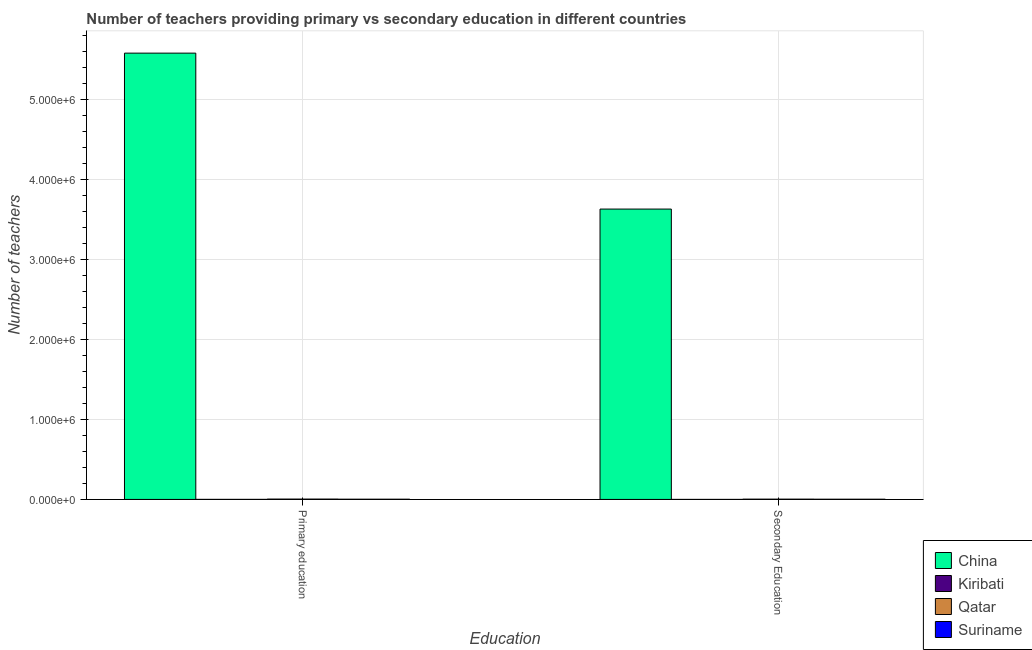Are the number of bars per tick equal to the number of legend labels?
Your answer should be very brief. Yes. Are the number of bars on each tick of the X-axis equal?
Give a very brief answer. Yes. How many bars are there on the 2nd tick from the right?
Your answer should be very brief. 4. What is the label of the 1st group of bars from the left?
Make the answer very short. Primary education. What is the number of secondary teachers in China?
Keep it short and to the point. 3.63e+06. Across all countries, what is the maximum number of primary teachers?
Ensure brevity in your answer.  5.58e+06. Across all countries, what is the minimum number of primary teachers?
Keep it short and to the point. 533. In which country was the number of secondary teachers minimum?
Make the answer very short. Kiribati. What is the total number of secondary teachers in the graph?
Your answer should be compact. 3.64e+06. What is the difference between the number of primary teachers in Kiribati and that in Qatar?
Provide a succinct answer. -3753. What is the difference between the number of secondary teachers in Suriname and the number of primary teachers in Kiribati?
Give a very brief answer. 1949. What is the average number of secondary teachers per country?
Offer a terse response. 9.09e+05. What is the difference between the number of secondary teachers and number of primary teachers in Kiribati?
Keep it short and to the point. -297. What is the ratio of the number of primary teachers in China to that in Suriname?
Offer a very short reply. 2078.11. In how many countries, is the number of primary teachers greater than the average number of primary teachers taken over all countries?
Your response must be concise. 1. What does the 1st bar from the right in Primary education represents?
Provide a short and direct response. Suriname. Are the values on the major ticks of Y-axis written in scientific E-notation?
Make the answer very short. Yes. Does the graph contain any zero values?
Keep it short and to the point. No. Does the graph contain grids?
Provide a succinct answer. Yes. Where does the legend appear in the graph?
Provide a short and direct response. Bottom right. What is the title of the graph?
Offer a terse response. Number of teachers providing primary vs secondary education in different countries. Does "Europe(all income levels)" appear as one of the legend labels in the graph?
Offer a very short reply. No. What is the label or title of the X-axis?
Make the answer very short. Education. What is the label or title of the Y-axis?
Offer a terse response. Number of teachers. What is the Number of teachers of China in Primary education?
Provide a succinct answer. 5.58e+06. What is the Number of teachers of Kiribati in Primary education?
Your response must be concise. 533. What is the Number of teachers in Qatar in Primary education?
Provide a succinct answer. 4286. What is the Number of teachers in Suriname in Primary education?
Offer a very short reply. 2686. What is the Number of teachers in China in Secondary Education?
Keep it short and to the point. 3.63e+06. What is the Number of teachers in Kiribati in Secondary Education?
Offer a very short reply. 236. What is the Number of teachers of Qatar in Secondary Education?
Provide a succinct answer. 3547. What is the Number of teachers in Suriname in Secondary Education?
Ensure brevity in your answer.  2482. Across all Education, what is the maximum Number of teachers in China?
Keep it short and to the point. 5.58e+06. Across all Education, what is the maximum Number of teachers of Kiribati?
Provide a short and direct response. 533. Across all Education, what is the maximum Number of teachers of Qatar?
Ensure brevity in your answer.  4286. Across all Education, what is the maximum Number of teachers in Suriname?
Provide a succinct answer. 2686. Across all Education, what is the minimum Number of teachers of China?
Your answer should be very brief. 3.63e+06. Across all Education, what is the minimum Number of teachers in Kiribati?
Your answer should be very brief. 236. Across all Education, what is the minimum Number of teachers in Qatar?
Provide a succinct answer. 3547. Across all Education, what is the minimum Number of teachers in Suriname?
Give a very brief answer. 2482. What is the total Number of teachers of China in the graph?
Make the answer very short. 9.21e+06. What is the total Number of teachers in Kiribati in the graph?
Offer a terse response. 769. What is the total Number of teachers of Qatar in the graph?
Make the answer very short. 7833. What is the total Number of teachers in Suriname in the graph?
Your answer should be compact. 5168. What is the difference between the Number of teachers in China in Primary education and that in Secondary Education?
Keep it short and to the point. 1.95e+06. What is the difference between the Number of teachers in Kiribati in Primary education and that in Secondary Education?
Provide a short and direct response. 297. What is the difference between the Number of teachers in Qatar in Primary education and that in Secondary Education?
Offer a very short reply. 739. What is the difference between the Number of teachers of Suriname in Primary education and that in Secondary Education?
Your answer should be very brief. 204. What is the difference between the Number of teachers of China in Primary education and the Number of teachers of Kiribati in Secondary Education?
Your response must be concise. 5.58e+06. What is the difference between the Number of teachers of China in Primary education and the Number of teachers of Qatar in Secondary Education?
Your answer should be compact. 5.58e+06. What is the difference between the Number of teachers in China in Primary education and the Number of teachers in Suriname in Secondary Education?
Offer a very short reply. 5.58e+06. What is the difference between the Number of teachers of Kiribati in Primary education and the Number of teachers of Qatar in Secondary Education?
Make the answer very short. -3014. What is the difference between the Number of teachers of Kiribati in Primary education and the Number of teachers of Suriname in Secondary Education?
Keep it short and to the point. -1949. What is the difference between the Number of teachers in Qatar in Primary education and the Number of teachers in Suriname in Secondary Education?
Make the answer very short. 1804. What is the average Number of teachers in China per Education?
Provide a succinct answer. 4.61e+06. What is the average Number of teachers of Kiribati per Education?
Give a very brief answer. 384.5. What is the average Number of teachers in Qatar per Education?
Your answer should be very brief. 3916.5. What is the average Number of teachers of Suriname per Education?
Make the answer very short. 2584. What is the difference between the Number of teachers of China and Number of teachers of Kiribati in Primary education?
Offer a very short reply. 5.58e+06. What is the difference between the Number of teachers in China and Number of teachers in Qatar in Primary education?
Your answer should be very brief. 5.58e+06. What is the difference between the Number of teachers of China and Number of teachers of Suriname in Primary education?
Keep it short and to the point. 5.58e+06. What is the difference between the Number of teachers in Kiribati and Number of teachers in Qatar in Primary education?
Your answer should be compact. -3753. What is the difference between the Number of teachers of Kiribati and Number of teachers of Suriname in Primary education?
Offer a terse response. -2153. What is the difference between the Number of teachers in Qatar and Number of teachers in Suriname in Primary education?
Provide a succinct answer. 1600. What is the difference between the Number of teachers of China and Number of teachers of Kiribati in Secondary Education?
Provide a succinct answer. 3.63e+06. What is the difference between the Number of teachers of China and Number of teachers of Qatar in Secondary Education?
Make the answer very short. 3.63e+06. What is the difference between the Number of teachers of China and Number of teachers of Suriname in Secondary Education?
Provide a short and direct response. 3.63e+06. What is the difference between the Number of teachers in Kiribati and Number of teachers in Qatar in Secondary Education?
Your answer should be compact. -3311. What is the difference between the Number of teachers of Kiribati and Number of teachers of Suriname in Secondary Education?
Your response must be concise. -2246. What is the difference between the Number of teachers of Qatar and Number of teachers of Suriname in Secondary Education?
Provide a short and direct response. 1065. What is the ratio of the Number of teachers of China in Primary education to that in Secondary Education?
Your response must be concise. 1.54. What is the ratio of the Number of teachers in Kiribati in Primary education to that in Secondary Education?
Ensure brevity in your answer.  2.26. What is the ratio of the Number of teachers in Qatar in Primary education to that in Secondary Education?
Give a very brief answer. 1.21. What is the ratio of the Number of teachers in Suriname in Primary education to that in Secondary Education?
Keep it short and to the point. 1.08. What is the difference between the highest and the second highest Number of teachers in China?
Keep it short and to the point. 1.95e+06. What is the difference between the highest and the second highest Number of teachers in Kiribati?
Offer a terse response. 297. What is the difference between the highest and the second highest Number of teachers of Qatar?
Provide a short and direct response. 739. What is the difference between the highest and the second highest Number of teachers in Suriname?
Give a very brief answer. 204. What is the difference between the highest and the lowest Number of teachers in China?
Ensure brevity in your answer.  1.95e+06. What is the difference between the highest and the lowest Number of teachers of Kiribati?
Your response must be concise. 297. What is the difference between the highest and the lowest Number of teachers of Qatar?
Ensure brevity in your answer.  739. What is the difference between the highest and the lowest Number of teachers in Suriname?
Ensure brevity in your answer.  204. 